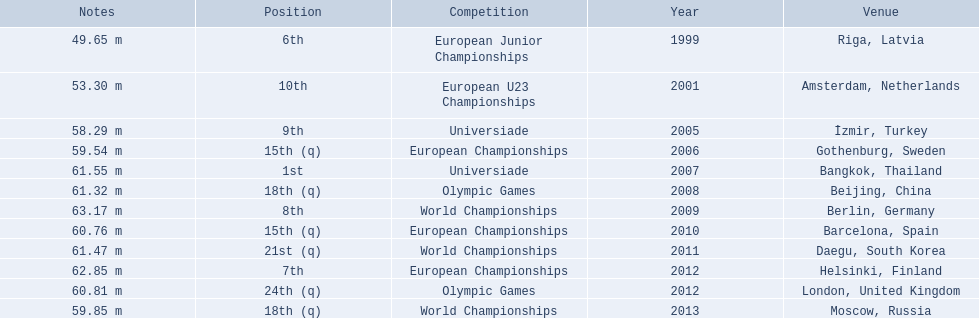What are all the competitions? European Junior Championships, European U23 Championships, Universiade, European Championships, Universiade, Olympic Games, World Championships, European Championships, World Championships, European Championships, Olympic Games, World Championships. What years did they place in the top 10? 1999, 2001, 2005, 2007, 2009, 2012. Besides when they placed first, which position was their highest? 6th. 